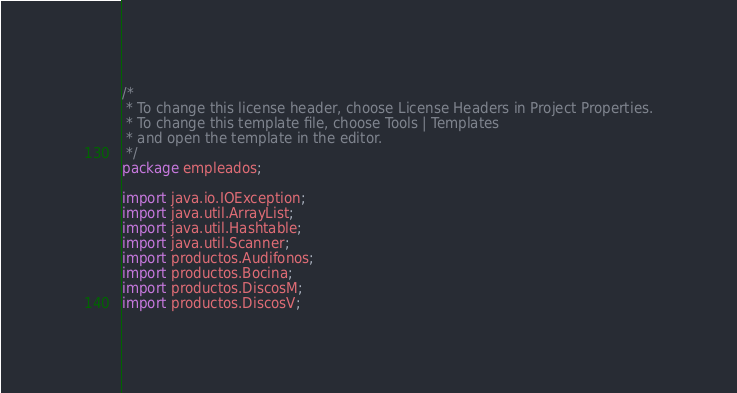Convert code to text. <code><loc_0><loc_0><loc_500><loc_500><_Java_>/*
 * To change this license header, choose License Headers in Project Properties.
 * To change this template file, choose Tools | Templates
 * and open the template in the editor.
 */
package empleados;

import java.io.IOException;
import java.util.ArrayList;
import java.util.Hashtable;
import java.util.Scanner;
import productos.Audifonos;
import productos.Bocina;
import productos.DiscosM;
import productos.DiscosV;</code> 